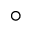<formula> <loc_0><loc_0><loc_500><loc_500>^ { \circ }</formula> 